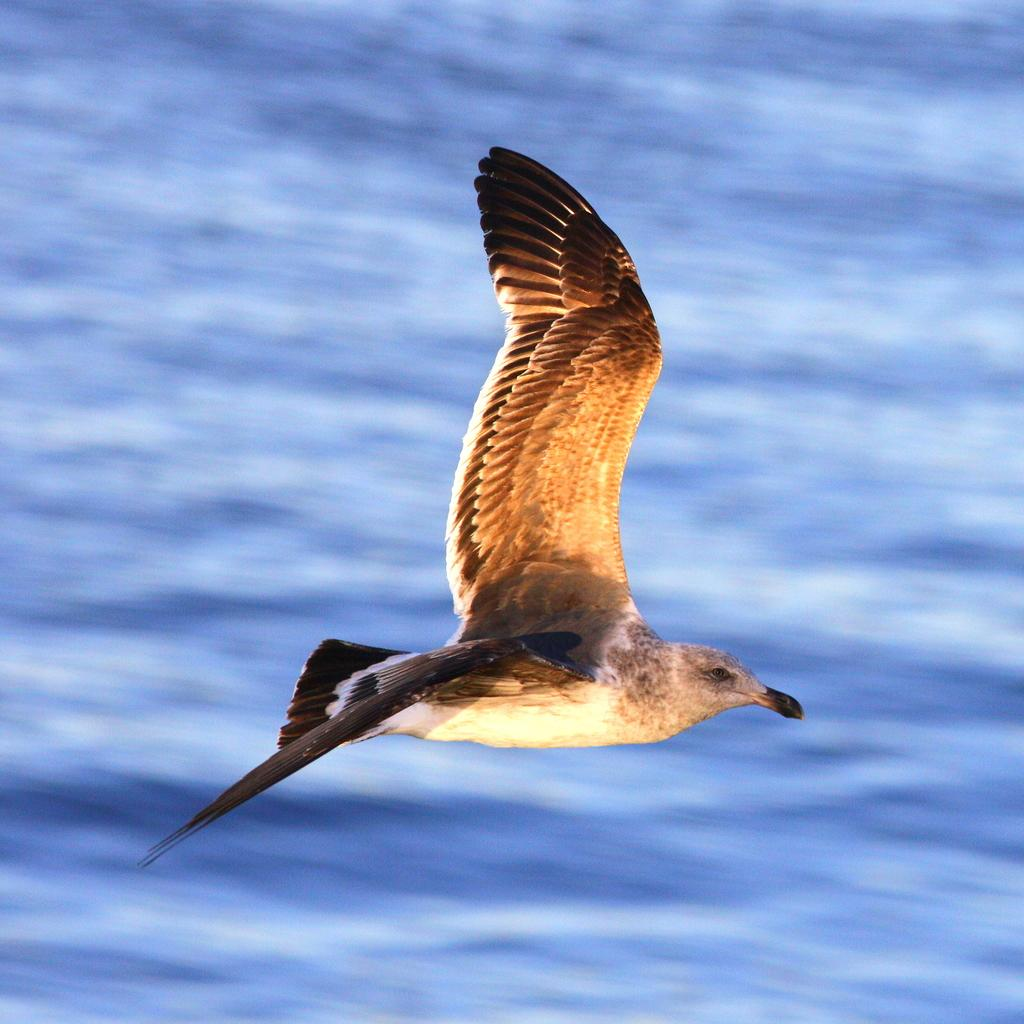What type of animal can be seen in the image? There is a bird in the image. Can you describe the colors of the bird? The bird has orange, brown, black, and cream colors. What is the bird doing in the image? The bird is flying in the air. What can be seen in the background of the image? The background of the image is blue and blurry. What type of tin can be seen in the image? There is no tin present in the image; it features a bird flying in the air. What items are on the list that the bird is holding in the image? There is no list or any items being held by the bird in the image. 